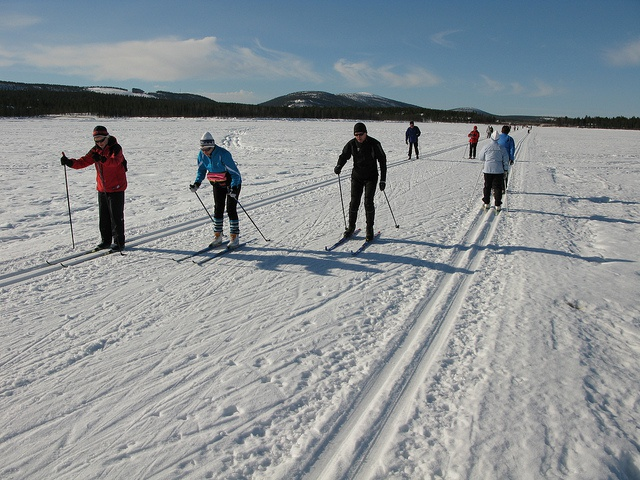Describe the objects in this image and their specific colors. I can see people in gray, black, maroon, and darkgray tones, people in gray, black, darkblue, and blue tones, people in gray, black, darkgray, and lightgray tones, people in gray, black, darkgray, and blue tones, and people in gray, black, darkgray, and maroon tones in this image. 